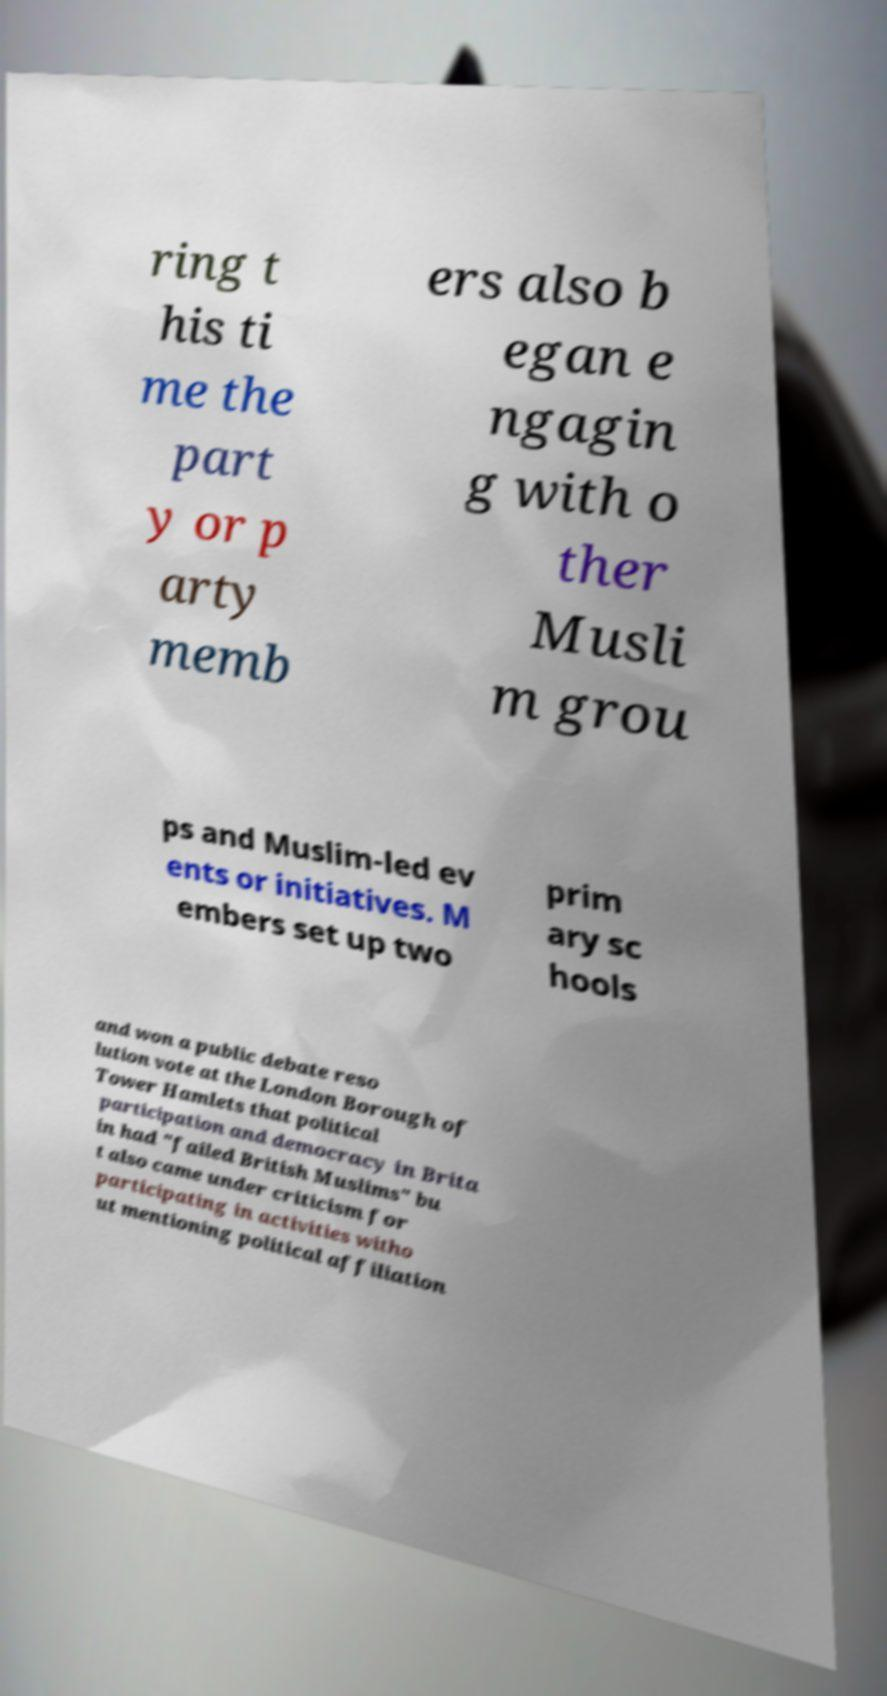Could you extract and type out the text from this image? ring t his ti me the part y or p arty memb ers also b egan e ngagin g with o ther Musli m grou ps and Muslim-led ev ents or initiatives. M embers set up two prim ary sc hools and won a public debate reso lution vote at the London Borough of Tower Hamlets that political participation and democracy in Brita in had "failed British Muslims" bu t also came under criticism for participating in activities witho ut mentioning political affiliation 